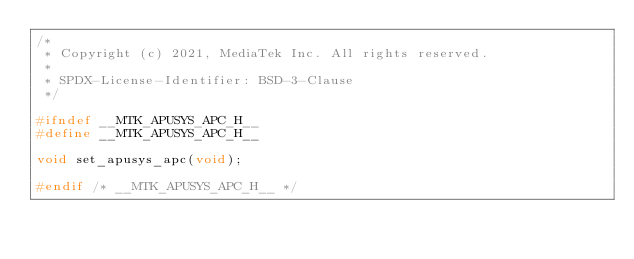Convert code to text. <code><loc_0><loc_0><loc_500><loc_500><_C_>/*
 * Copyright (c) 2021, MediaTek Inc. All rights reserved.
 *
 * SPDX-License-Identifier: BSD-3-Clause
 */

#ifndef __MTK_APUSYS_APC_H__
#define __MTK_APUSYS_APC_H__

void set_apusys_apc(void);

#endif /* __MTK_APUSYS_APC_H__ */
</code> 